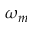<formula> <loc_0><loc_0><loc_500><loc_500>\omega _ { m }</formula> 